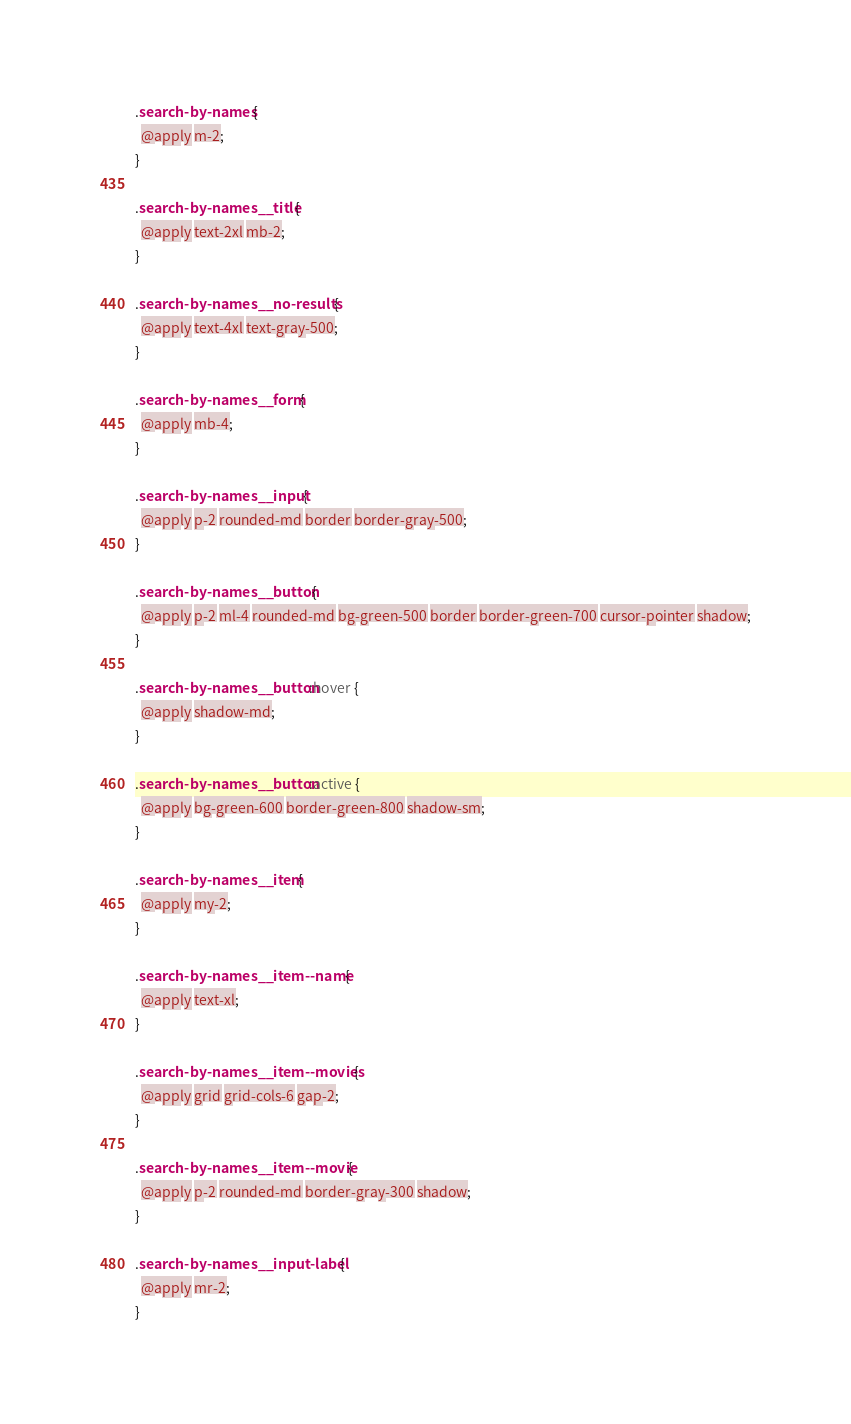<code> <loc_0><loc_0><loc_500><loc_500><_CSS_>.search-by-names {
  @apply m-2;
}

.search-by-names__title {
  @apply text-2xl mb-2;
}

.search-by-names__no-results {
  @apply text-4xl text-gray-500;
}

.search-by-names__form {
  @apply mb-4;
}

.search-by-names__input {
  @apply p-2 rounded-md border border-gray-500;
}

.search-by-names__button {
  @apply p-2 ml-4 rounded-md bg-green-500 border border-green-700 cursor-pointer shadow;
}

.search-by-names__button:hover {
  @apply shadow-md;
}

.search-by-names__button:active {
  @apply bg-green-600 border-green-800 shadow-sm;
}

.search-by-names__item {
  @apply my-2;
}

.search-by-names__item--name {
  @apply text-xl;
}

.search-by-names__item--movies {
  @apply grid grid-cols-6 gap-2;
}

.search-by-names__item--movie {
  @apply p-2 rounded-md border-gray-300 shadow;
}

.search-by-names__input-label {
  @apply mr-2;
}
</code> 